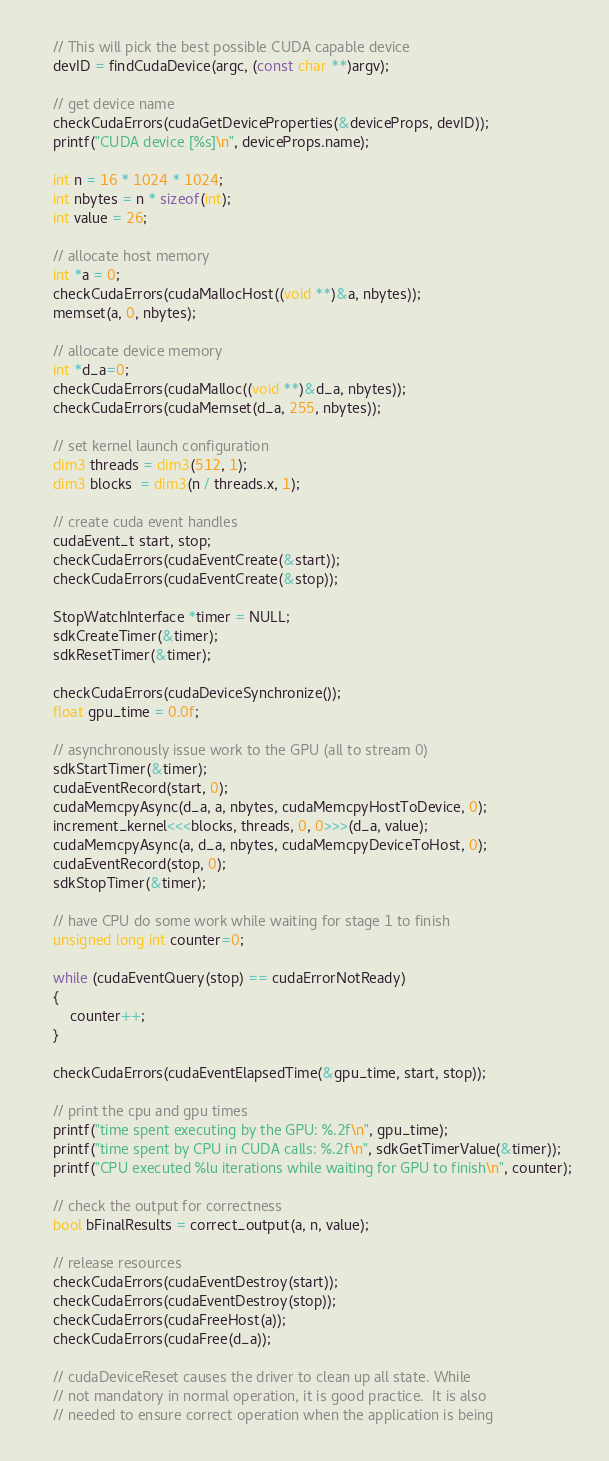<code> <loc_0><loc_0><loc_500><loc_500><_Cuda_>
    // This will pick the best possible CUDA capable device
    devID = findCudaDevice(argc, (const char **)argv);

    // get device name
    checkCudaErrors(cudaGetDeviceProperties(&deviceProps, devID));
    printf("CUDA device [%s]\n", deviceProps.name);

    int n = 16 * 1024 * 1024;
    int nbytes = n * sizeof(int);
    int value = 26;

    // allocate host memory
    int *a = 0;
    checkCudaErrors(cudaMallocHost((void **)&a, nbytes));
    memset(a, 0, nbytes);

    // allocate device memory
    int *d_a=0;
    checkCudaErrors(cudaMalloc((void **)&d_a, nbytes));
    checkCudaErrors(cudaMemset(d_a, 255, nbytes));

    // set kernel launch configuration
    dim3 threads = dim3(512, 1);
    dim3 blocks  = dim3(n / threads.x, 1);

    // create cuda event handles
    cudaEvent_t start, stop;
    checkCudaErrors(cudaEventCreate(&start));
    checkCudaErrors(cudaEventCreate(&stop));

    StopWatchInterface *timer = NULL;
    sdkCreateTimer(&timer);
    sdkResetTimer(&timer);

    checkCudaErrors(cudaDeviceSynchronize());
    float gpu_time = 0.0f;

    // asynchronously issue work to the GPU (all to stream 0)
    sdkStartTimer(&timer);
    cudaEventRecord(start, 0);
    cudaMemcpyAsync(d_a, a, nbytes, cudaMemcpyHostToDevice, 0);
    increment_kernel<<<blocks, threads, 0, 0>>>(d_a, value);
    cudaMemcpyAsync(a, d_a, nbytes, cudaMemcpyDeviceToHost, 0);
    cudaEventRecord(stop, 0);
    sdkStopTimer(&timer);

    // have CPU do some work while waiting for stage 1 to finish
    unsigned long int counter=0;

    while (cudaEventQuery(stop) == cudaErrorNotReady)
    {
        counter++;
    }

    checkCudaErrors(cudaEventElapsedTime(&gpu_time, start, stop));

    // print the cpu and gpu times
    printf("time spent executing by the GPU: %.2f\n", gpu_time);
    printf("time spent by CPU in CUDA calls: %.2f\n", sdkGetTimerValue(&timer));
    printf("CPU executed %lu iterations while waiting for GPU to finish\n", counter);

    // check the output for correctness
    bool bFinalResults = correct_output(a, n, value);

    // release resources
    checkCudaErrors(cudaEventDestroy(start));
    checkCudaErrors(cudaEventDestroy(stop));
    checkCudaErrors(cudaFreeHost(a));
    checkCudaErrors(cudaFree(d_a));

    // cudaDeviceReset causes the driver to clean up all state. While
    // not mandatory in normal operation, it is good practice.  It is also
    // needed to ensure correct operation when the application is being</code> 